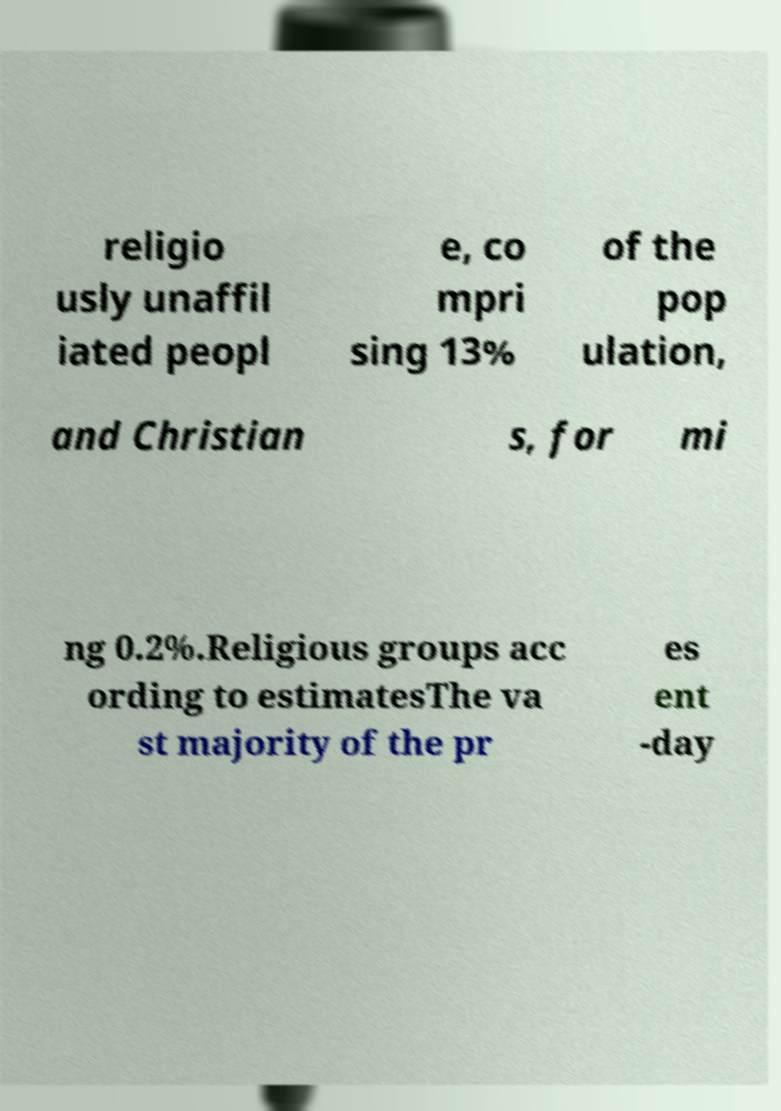Please read and relay the text visible in this image. What does it say? religio usly unaffil iated peopl e, co mpri sing 13% of the pop ulation, and Christian s, for mi ng 0.2%.Religious groups acc ording to estimatesThe va st majority of the pr es ent -day 